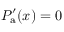Convert formula to latex. <formula><loc_0><loc_0><loc_500><loc_500>P _ { a } ^ { \prime } ( x ) = 0</formula> 